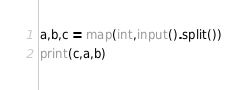Convert code to text. <code><loc_0><loc_0><loc_500><loc_500><_Python_>a,b,c = map(int,input().split())
print(c,a,b)</code> 